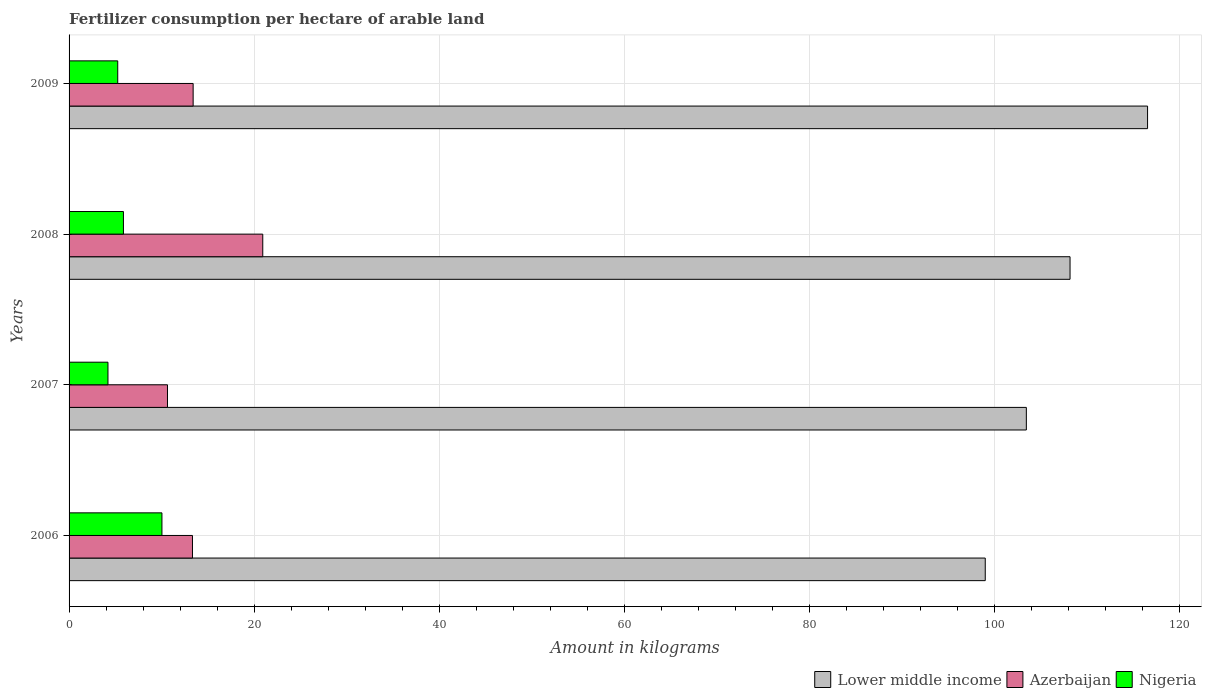How many different coloured bars are there?
Ensure brevity in your answer.  3. How many groups of bars are there?
Offer a very short reply. 4. Are the number of bars per tick equal to the number of legend labels?
Offer a terse response. Yes. Are the number of bars on each tick of the Y-axis equal?
Your answer should be very brief. Yes. How many bars are there on the 2nd tick from the bottom?
Offer a terse response. 3. In how many cases, is the number of bars for a given year not equal to the number of legend labels?
Ensure brevity in your answer.  0. What is the amount of fertilizer consumption in Azerbaijan in 2006?
Your answer should be very brief. 13.34. Across all years, what is the maximum amount of fertilizer consumption in Lower middle income?
Your answer should be very brief. 116.58. Across all years, what is the minimum amount of fertilizer consumption in Azerbaijan?
Your answer should be very brief. 10.64. In which year was the amount of fertilizer consumption in Nigeria maximum?
Provide a short and direct response. 2006. In which year was the amount of fertilizer consumption in Nigeria minimum?
Give a very brief answer. 2007. What is the total amount of fertilizer consumption in Lower middle income in the graph?
Offer a terse response. 427.28. What is the difference between the amount of fertilizer consumption in Azerbaijan in 2007 and that in 2009?
Ensure brevity in your answer.  -2.77. What is the difference between the amount of fertilizer consumption in Nigeria in 2009 and the amount of fertilizer consumption in Lower middle income in 2008?
Your answer should be very brief. -102.94. What is the average amount of fertilizer consumption in Azerbaijan per year?
Give a very brief answer. 14.58. In the year 2008, what is the difference between the amount of fertilizer consumption in Azerbaijan and amount of fertilizer consumption in Nigeria?
Your answer should be very brief. 15.06. In how many years, is the amount of fertilizer consumption in Nigeria greater than 32 kg?
Provide a succinct answer. 0. What is the ratio of the amount of fertilizer consumption in Lower middle income in 2006 to that in 2008?
Provide a succinct answer. 0.92. Is the difference between the amount of fertilizer consumption in Azerbaijan in 2008 and 2009 greater than the difference between the amount of fertilizer consumption in Nigeria in 2008 and 2009?
Provide a succinct answer. Yes. What is the difference between the highest and the second highest amount of fertilizer consumption in Azerbaijan?
Keep it short and to the point. 7.53. What is the difference between the highest and the lowest amount of fertilizer consumption in Lower middle income?
Give a very brief answer. 17.55. What does the 1st bar from the top in 2007 represents?
Your response must be concise. Nigeria. What does the 3rd bar from the bottom in 2008 represents?
Provide a succinct answer. Nigeria. How many bars are there?
Ensure brevity in your answer.  12. Are all the bars in the graph horizontal?
Your answer should be compact. Yes. How many years are there in the graph?
Give a very brief answer. 4. Does the graph contain any zero values?
Your answer should be very brief. No. Where does the legend appear in the graph?
Ensure brevity in your answer.  Bottom right. How many legend labels are there?
Your response must be concise. 3. What is the title of the graph?
Your answer should be very brief. Fertilizer consumption per hectare of arable land. Does "Arab World" appear as one of the legend labels in the graph?
Your answer should be compact. No. What is the label or title of the X-axis?
Offer a terse response. Amount in kilograms. What is the label or title of the Y-axis?
Provide a succinct answer. Years. What is the Amount in kilograms of Lower middle income in 2006?
Give a very brief answer. 99.03. What is the Amount in kilograms of Azerbaijan in 2006?
Your answer should be compact. 13.34. What is the Amount in kilograms of Nigeria in 2006?
Provide a short and direct response. 10.04. What is the Amount in kilograms of Lower middle income in 2007?
Ensure brevity in your answer.  103.48. What is the Amount in kilograms in Azerbaijan in 2007?
Give a very brief answer. 10.64. What is the Amount in kilograms in Nigeria in 2007?
Provide a succinct answer. 4.21. What is the Amount in kilograms in Lower middle income in 2008?
Offer a terse response. 108.2. What is the Amount in kilograms in Azerbaijan in 2008?
Your answer should be very brief. 20.94. What is the Amount in kilograms of Nigeria in 2008?
Ensure brevity in your answer.  5.88. What is the Amount in kilograms in Lower middle income in 2009?
Offer a very short reply. 116.58. What is the Amount in kilograms of Azerbaijan in 2009?
Offer a very short reply. 13.41. What is the Amount in kilograms of Nigeria in 2009?
Your answer should be very brief. 5.26. Across all years, what is the maximum Amount in kilograms of Lower middle income?
Provide a succinct answer. 116.58. Across all years, what is the maximum Amount in kilograms in Azerbaijan?
Your response must be concise. 20.94. Across all years, what is the maximum Amount in kilograms in Nigeria?
Ensure brevity in your answer.  10.04. Across all years, what is the minimum Amount in kilograms of Lower middle income?
Your response must be concise. 99.03. Across all years, what is the minimum Amount in kilograms of Azerbaijan?
Offer a terse response. 10.64. Across all years, what is the minimum Amount in kilograms in Nigeria?
Your response must be concise. 4.21. What is the total Amount in kilograms in Lower middle income in the graph?
Your response must be concise. 427.28. What is the total Amount in kilograms in Azerbaijan in the graph?
Your response must be concise. 58.33. What is the total Amount in kilograms in Nigeria in the graph?
Provide a succinct answer. 25.38. What is the difference between the Amount in kilograms of Lower middle income in 2006 and that in 2007?
Your answer should be compact. -4.44. What is the difference between the Amount in kilograms of Azerbaijan in 2006 and that in 2007?
Offer a terse response. 2.7. What is the difference between the Amount in kilograms in Nigeria in 2006 and that in 2007?
Provide a short and direct response. 5.83. What is the difference between the Amount in kilograms in Lower middle income in 2006 and that in 2008?
Give a very brief answer. -9.17. What is the difference between the Amount in kilograms in Azerbaijan in 2006 and that in 2008?
Offer a very short reply. -7.6. What is the difference between the Amount in kilograms in Nigeria in 2006 and that in 2008?
Your response must be concise. 4.16. What is the difference between the Amount in kilograms of Lower middle income in 2006 and that in 2009?
Offer a very short reply. -17.55. What is the difference between the Amount in kilograms in Azerbaijan in 2006 and that in 2009?
Your response must be concise. -0.07. What is the difference between the Amount in kilograms in Nigeria in 2006 and that in 2009?
Offer a terse response. 4.78. What is the difference between the Amount in kilograms in Lower middle income in 2007 and that in 2008?
Provide a succinct answer. -4.72. What is the difference between the Amount in kilograms in Nigeria in 2007 and that in 2008?
Provide a succinct answer. -1.67. What is the difference between the Amount in kilograms in Lower middle income in 2007 and that in 2009?
Ensure brevity in your answer.  -13.1. What is the difference between the Amount in kilograms of Azerbaijan in 2007 and that in 2009?
Your answer should be very brief. -2.77. What is the difference between the Amount in kilograms in Nigeria in 2007 and that in 2009?
Offer a very short reply. -1.06. What is the difference between the Amount in kilograms in Lower middle income in 2008 and that in 2009?
Offer a very short reply. -8.38. What is the difference between the Amount in kilograms in Azerbaijan in 2008 and that in 2009?
Give a very brief answer. 7.53. What is the difference between the Amount in kilograms in Nigeria in 2008 and that in 2009?
Offer a terse response. 0.62. What is the difference between the Amount in kilograms of Lower middle income in 2006 and the Amount in kilograms of Azerbaijan in 2007?
Keep it short and to the point. 88.4. What is the difference between the Amount in kilograms in Lower middle income in 2006 and the Amount in kilograms in Nigeria in 2007?
Keep it short and to the point. 94.83. What is the difference between the Amount in kilograms in Azerbaijan in 2006 and the Amount in kilograms in Nigeria in 2007?
Give a very brief answer. 9.13. What is the difference between the Amount in kilograms of Lower middle income in 2006 and the Amount in kilograms of Azerbaijan in 2008?
Your answer should be very brief. 78.1. What is the difference between the Amount in kilograms of Lower middle income in 2006 and the Amount in kilograms of Nigeria in 2008?
Your answer should be very brief. 93.16. What is the difference between the Amount in kilograms of Azerbaijan in 2006 and the Amount in kilograms of Nigeria in 2008?
Your response must be concise. 7.46. What is the difference between the Amount in kilograms in Lower middle income in 2006 and the Amount in kilograms in Azerbaijan in 2009?
Your response must be concise. 85.62. What is the difference between the Amount in kilograms in Lower middle income in 2006 and the Amount in kilograms in Nigeria in 2009?
Keep it short and to the point. 93.77. What is the difference between the Amount in kilograms of Azerbaijan in 2006 and the Amount in kilograms of Nigeria in 2009?
Give a very brief answer. 8.08. What is the difference between the Amount in kilograms of Lower middle income in 2007 and the Amount in kilograms of Azerbaijan in 2008?
Your answer should be compact. 82.54. What is the difference between the Amount in kilograms of Lower middle income in 2007 and the Amount in kilograms of Nigeria in 2008?
Your answer should be very brief. 97.6. What is the difference between the Amount in kilograms in Azerbaijan in 2007 and the Amount in kilograms in Nigeria in 2008?
Offer a terse response. 4.76. What is the difference between the Amount in kilograms of Lower middle income in 2007 and the Amount in kilograms of Azerbaijan in 2009?
Provide a short and direct response. 90.06. What is the difference between the Amount in kilograms in Lower middle income in 2007 and the Amount in kilograms in Nigeria in 2009?
Ensure brevity in your answer.  98.21. What is the difference between the Amount in kilograms of Azerbaijan in 2007 and the Amount in kilograms of Nigeria in 2009?
Ensure brevity in your answer.  5.38. What is the difference between the Amount in kilograms in Lower middle income in 2008 and the Amount in kilograms in Azerbaijan in 2009?
Keep it short and to the point. 94.79. What is the difference between the Amount in kilograms of Lower middle income in 2008 and the Amount in kilograms of Nigeria in 2009?
Your answer should be very brief. 102.94. What is the difference between the Amount in kilograms in Azerbaijan in 2008 and the Amount in kilograms in Nigeria in 2009?
Your response must be concise. 15.68. What is the average Amount in kilograms in Lower middle income per year?
Ensure brevity in your answer.  106.82. What is the average Amount in kilograms in Azerbaijan per year?
Provide a short and direct response. 14.58. What is the average Amount in kilograms of Nigeria per year?
Your answer should be very brief. 6.35. In the year 2006, what is the difference between the Amount in kilograms of Lower middle income and Amount in kilograms of Azerbaijan?
Your response must be concise. 85.69. In the year 2006, what is the difference between the Amount in kilograms of Lower middle income and Amount in kilograms of Nigeria?
Offer a terse response. 88.99. In the year 2006, what is the difference between the Amount in kilograms in Azerbaijan and Amount in kilograms in Nigeria?
Ensure brevity in your answer.  3.3. In the year 2007, what is the difference between the Amount in kilograms in Lower middle income and Amount in kilograms in Azerbaijan?
Provide a short and direct response. 92.84. In the year 2007, what is the difference between the Amount in kilograms of Lower middle income and Amount in kilograms of Nigeria?
Offer a terse response. 99.27. In the year 2007, what is the difference between the Amount in kilograms in Azerbaijan and Amount in kilograms in Nigeria?
Provide a short and direct response. 6.43. In the year 2008, what is the difference between the Amount in kilograms in Lower middle income and Amount in kilograms in Azerbaijan?
Your response must be concise. 87.26. In the year 2008, what is the difference between the Amount in kilograms in Lower middle income and Amount in kilograms in Nigeria?
Ensure brevity in your answer.  102.32. In the year 2008, what is the difference between the Amount in kilograms of Azerbaijan and Amount in kilograms of Nigeria?
Provide a succinct answer. 15.06. In the year 2009, what is the difference between the Amount in kilograms of Lower middle income and Amount in kilograms of Azerbaijan?
Offer a very short reply. 103.17. In the year 2009, what is the difference between the Amount in kilograms of Lower middle income and Amount in kilograms of Nigeria?
Your answer should be compact. 111.32. In the year 2009, what is the difference between the Amount in kilograms in Azerbaijan and Amount in kilograms in Nigeria?
Provide a short and direct response. 8.15. What is the ratio of the Amount in kilograms in Lower middle income in 2006 to that in 2007?
Offer a very short reply. 0.96. What is the ratio of the Amount in kilograms of Azerbaijan in 2006 to that in 2007?
Make the answer very short. 1.25. What is the ratio of the Amount in kilograms of Nigeria in 2006 to that in 2007?
Your answer should be compact. 2.39. What is the ratio of the Amount in kilograms in Lower middle income in 2006 to that in 2008?
Offer a very short reply. 0.92. What is the ratio of the Amount in kilograms of Azerbaijan in 2006 to that in 2008?
Your answer should be very brief. 0.64. What is the ratio of the Amount in kilograms of Nigeria in 2006 to that in 2008?
Keep it short and to the point. 1.71. What is the ratio of the Amount in kilograms of Lower middle income in 2006 to that in 2009?
Your response must be concise. 0.85. What is the ratio of the Amount in kilograms of Nigeria in 2006 to that in 2009?
Ensure brevity in your answer.  1.91. What is the ratio of the Amount in kilograms of Lower middle income in 2007 to that in 2008?
Provide a succinct answer. 0.96. What is the ratio of the Amount in kilograms of Azerbaijan in 2007 to that in 2008?
Offer a terse response. 0.51. What is the ratio of the Amount in kilograms of Nigeria in 2007 to that in 2008?
Make the answer very short. 0.72. What is the ratio of the Amount in kilograms of Lower middle income in 2007 to that in 2009?
Ensure brevity in your answer.  0.89. What is the ratio of the Amount in kilograms of Azerbaijan in 2007 to that in 2009?
Keep it short and to the point. 0.79. What is the ratio of the Amount in kilograms in Nigeria in 2007 to that in 2009?
Offer a terse response. 0.8. What is the ratio of the Amount in kilograms of Lower middle income in 2008 to that in 2009?
Offer a very short reply. 0.93. What is the ratio of the Amount in kilograms of Azerbaijan in 2008 to that in 2009?
Your response must be concise. 1.56. What is the ratio of the Amount in kilograms in Nigeria in 2008 to that in 2009?
Provide a succinct answer. 1.12. What is the difference between the highest and the second highest Amount in kilograms of Lower middle income?
Your answer should be very brief. 8.38. What is the difference between the highest and the second highest Amount in kilograms in Azerbaijan?
Offer a very short reply. 7.53. What is the difference between the highest and the second highest Amount in kilograms in Nigeria?
Your answer should be compact. 4.16. What is the difference between the highest and the lowest Amount in kilograms of Lower middle income?
Ensure brevity in your answer.  17.55. What is the difference between the highest and the lowest Amount in kilograms of Azerbaijan?
Your answer should be very brief. 10.3. What is the difference between the highest and the lowest Amount in kilograms of Nigeria?
Your answer should be compact. 5.83. 